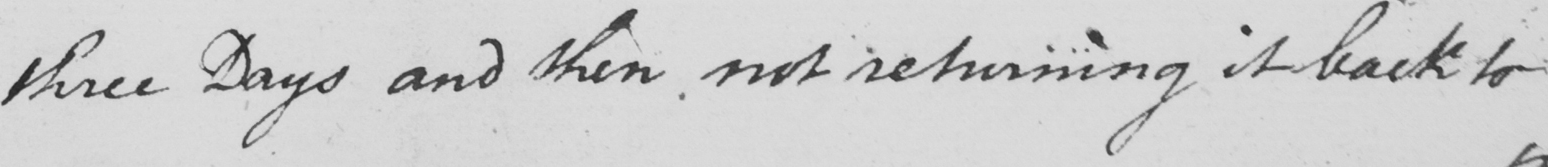What text is written in this handwritten line? three Days and then not returning it back to 